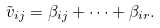Convert formula to latex. <formula><loc_0><loc_0><loc_500><loc_500>\tilde { v } _ { i j } = \beta _ { i j } + \dots + \beta _ { i r } .</formula> 